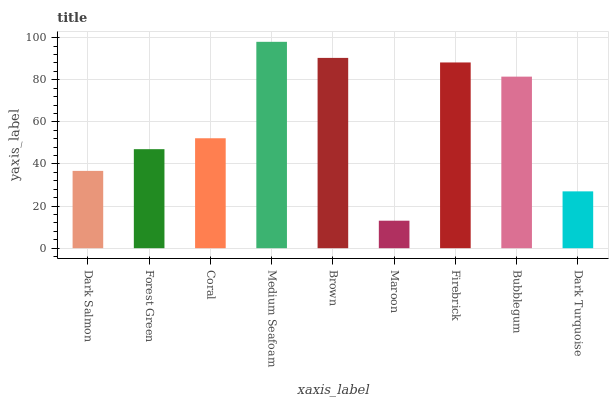Is Forest Green the minimum?
Answer yes or no. No. Is Forest Green the maximum?
Answer yes or no. No. Is Forest Green greater than Dark Salmon?
Answer yes or no. Yes. Is Dark Salmon less than Forest Green?
Answer yes or no. Yes. Is Dark Salmon greater than Forest Green?
Answer yes or no. No. Is Forest Green less than Dark Salmon?
Answer yes or no. No. Is Coral the high median?
Answer yes or no. Yes. Is Coral the low median?
Answer yes or no. Yes. Is Dark Salmon the high median?
Answer yes or no. No. Is Brown the low median?
Answer yes or no. No. 